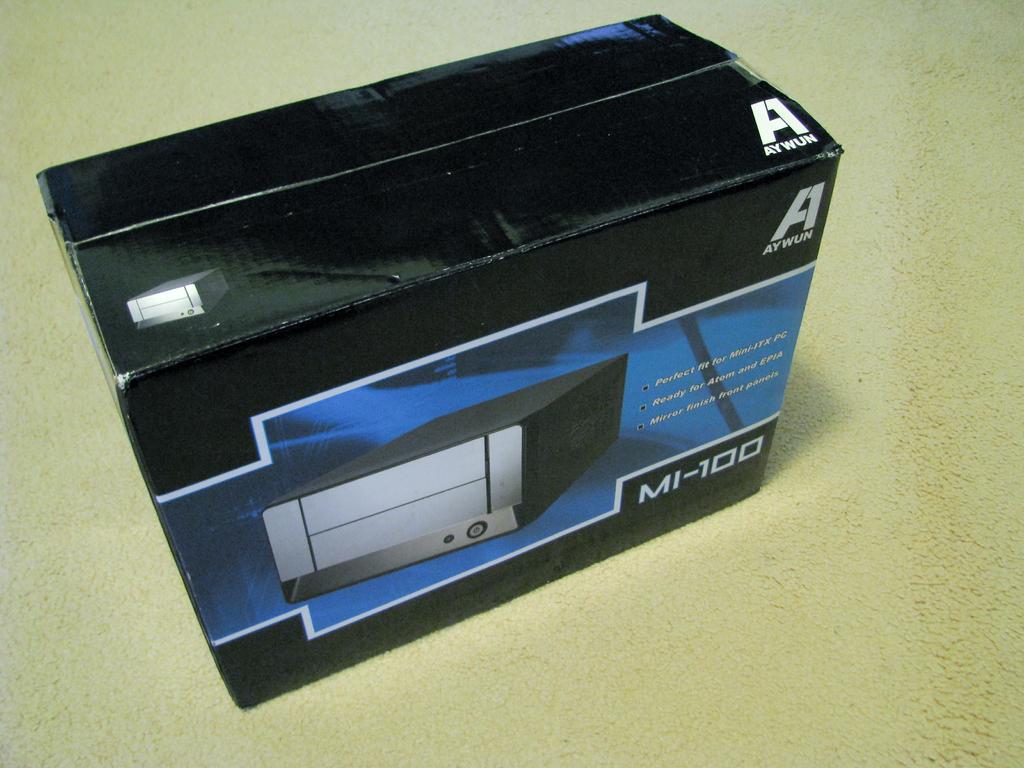What model of product is this?
Ensure brevity in your answer.  Mi-100. 